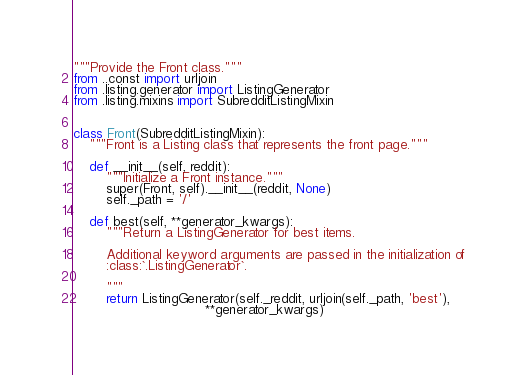Convert code to text. <code><loc_0><loc_0><loc_500><loc_500><_Python_>"""Provide the Front class."""
from ..const import urljoin
from .listing.generator import ListingGenerator
from .listing.mixins import SubredditListingMixin


class Front(SubredditListingMixin):
    """Front is a Listing class that represents the front page."""

    def __init__(self, reddit):
        """Initialize a Front instance."""
        super(Front, self).__init__(reddit, None)
        self._path = '/'

    def best(self, **generator_kwargs):
        """Return a ListingGenerator for best items.

        Additional keyword arguments are passed in the initialization of
        :class:`.ListingGenerator`.

        """
        return ListingGenerator(self._reddit, urljoin(self._path, 'best'),
                                **generator_kwargs)
</code> 